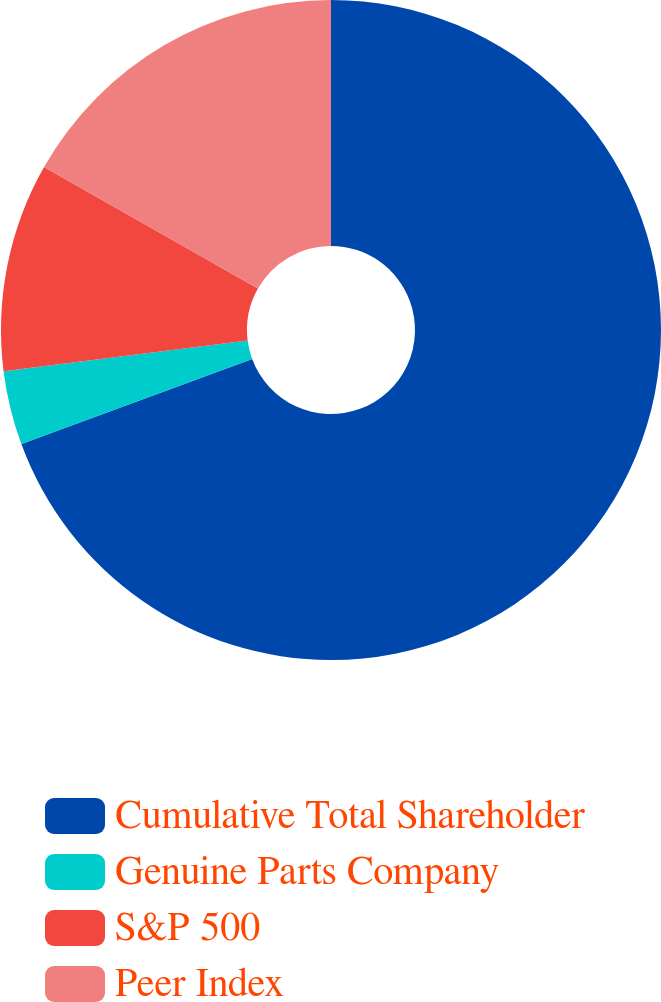Convert chart to OTSL. <chart><loc_0><loc_0><loc_500><loc_500><pie_chart><fcel>Cumulative Total Shareholder<fcel>Genuine Parts Company<fcel>S&P 500<fcel>Peer Index<nl><fcel>69.38%<fcel>3.63%<fcel>10.21%<fcel>16.78%<nl></chart> 